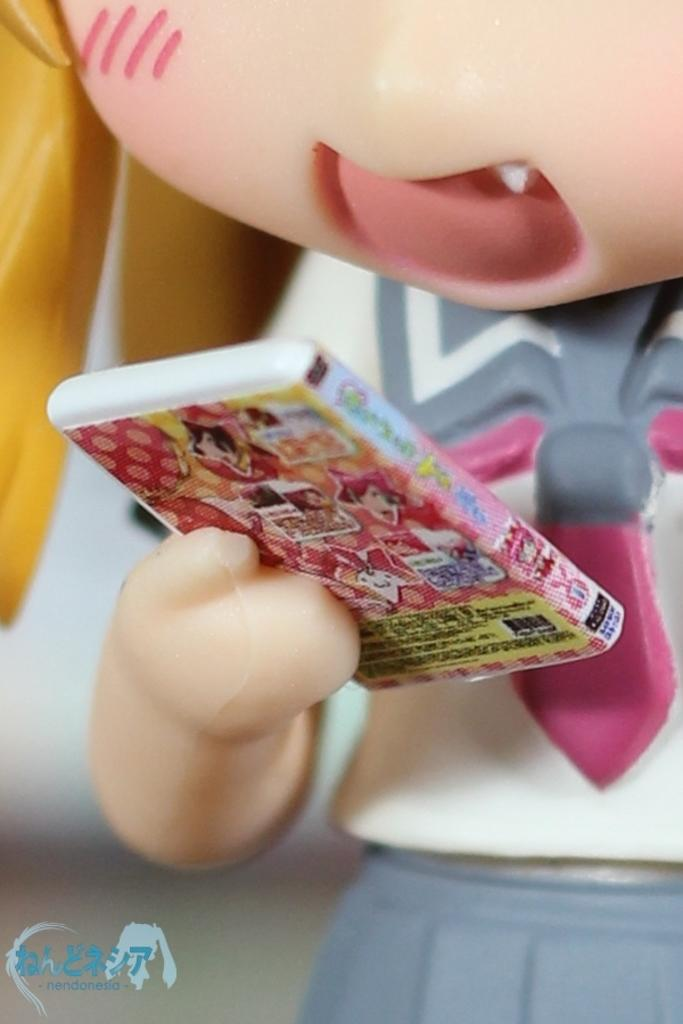What type of toy is in the image? There is a person toy in the image. What is the person toy holding? The person toy is holding a book. Is there any text visible in the image? Yes, there is some text in the left bottom of the image. Can you tell me how many hens are in the image? There are no hens present in the image. What type of agreement is the person toy making in the image? The person toy is holding a book, not making any agreements in the image. 